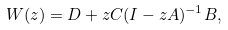<formula> <loc_0><loc_0><loc_500><loc_500>W ( z ) = D + z C ( I - z A ) ^ { - 1 } B ,</formula> 